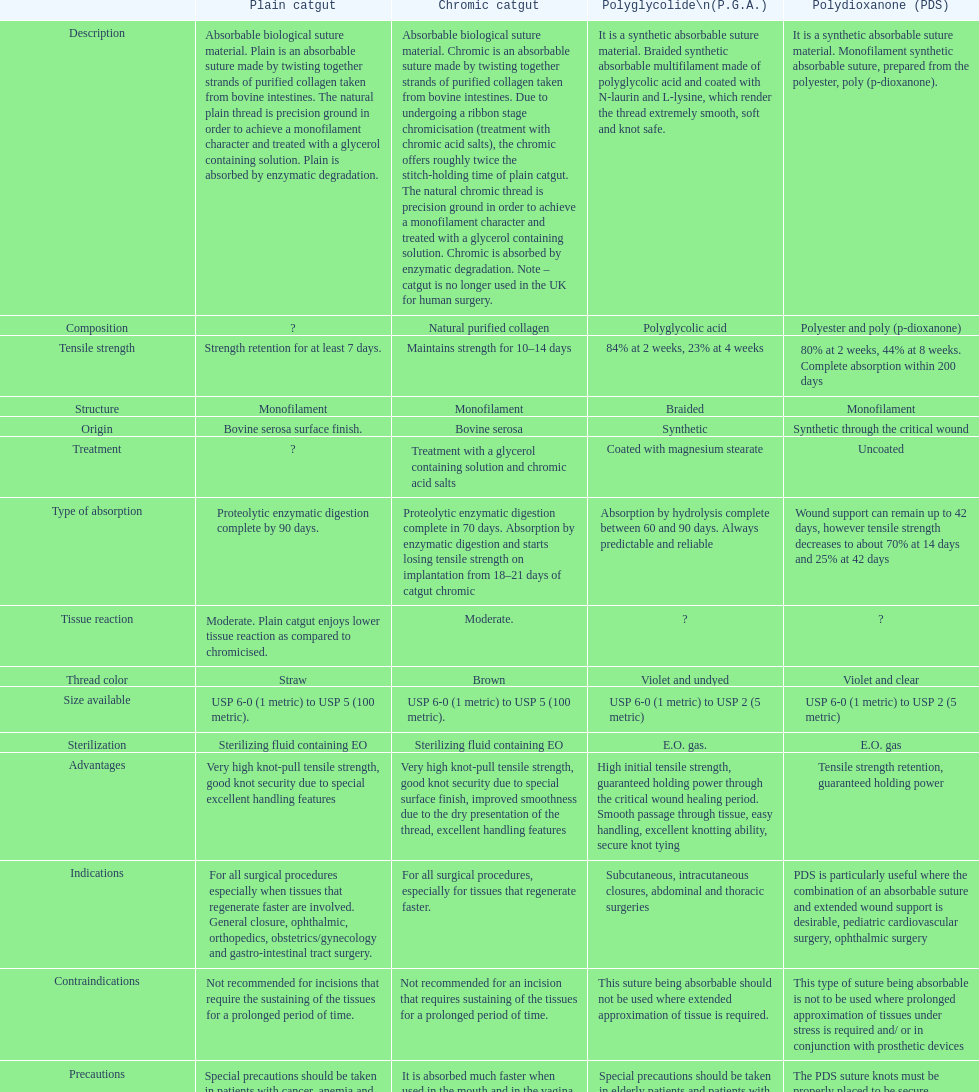What is the composition apart from monofilament? Braided. 